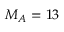<formula> <loc_0><loc_0><loc_500><loc_500>M _ { A } = 1 3</formula> 